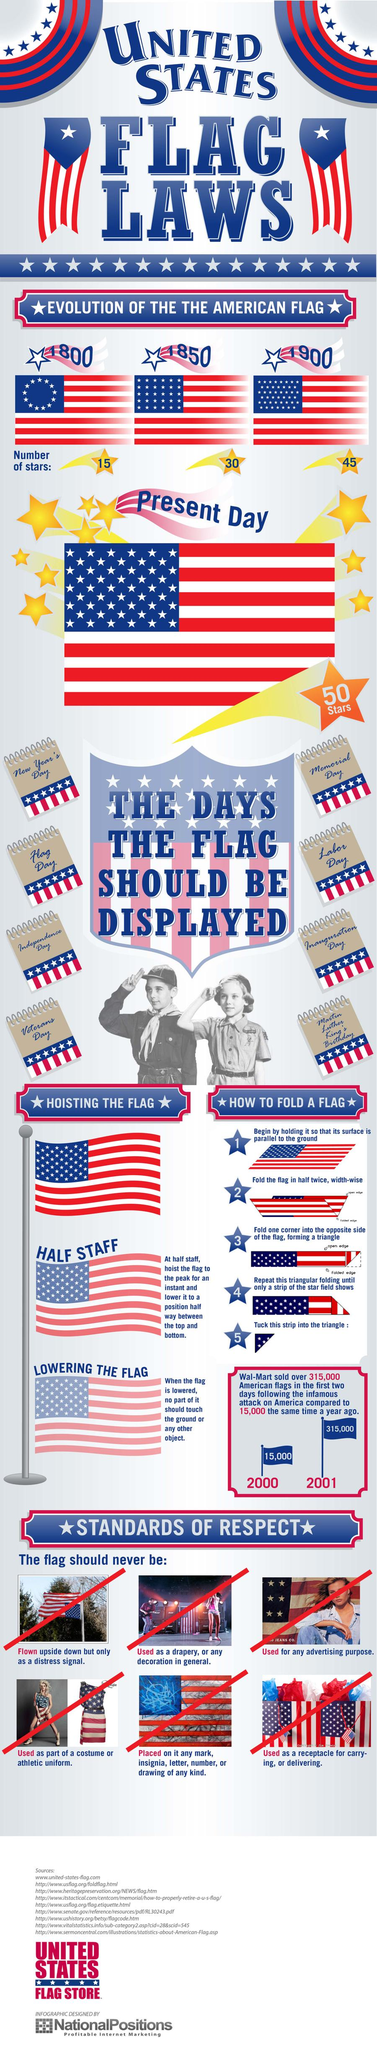List a handful of essential elements in this visual. There are currently 50 stars on the U.S. flag, as of today. In the year 2001, Walmart sold a total of 315,000 American flags. The number of stars on the U.S. flag in the year 1850 was 30. In the year 1900, the U.S. flag contained 45 stars. In the year 2000, Walmart sold 15,000 American flags. 